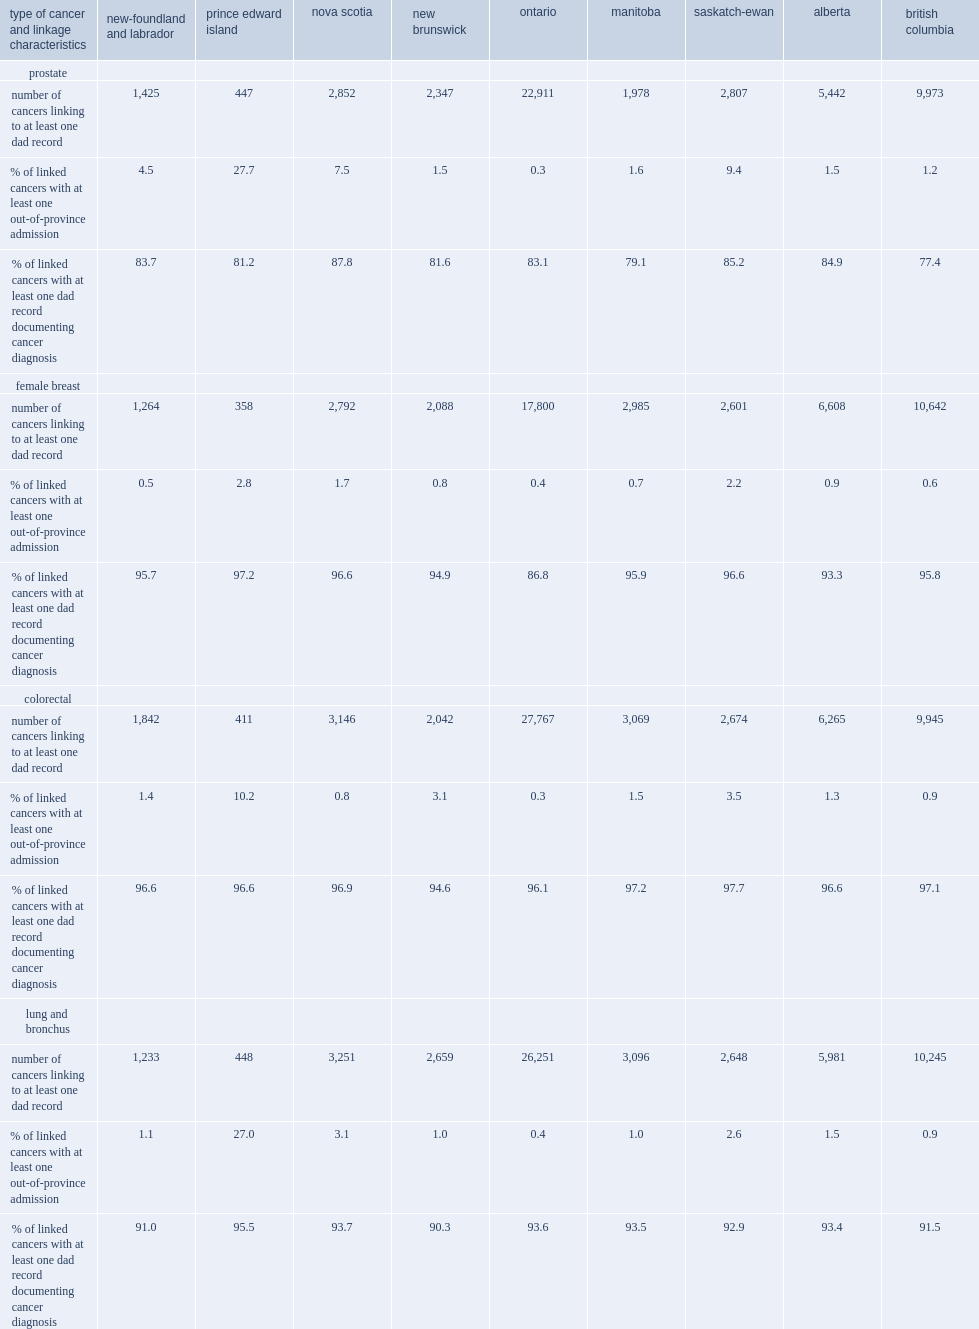List the cancer which was most likely and least likely to link to an out-of-province hospital admission respectively. Prostate female breast. For prostate cancers,which province had the highest percentage linking to at least one out-of-province admission? Prince edward island. List the cancer which was least likely and most likely to link to at least one dad record with a consistent cancer diagnosis respectively. Prostate colorectal. Could you parse the entire table? {'header': ['type of cancer and linkage characteristics', 'new-foundland and labrador', 'prince edward island', 'nova scotia', 'new brunswick', 'ontario', 'manitoba', 'saskatch-ewan', 'alberta', 'british columbia'], 'rows': [['prostate', '', '', '', '', '', '', '', '', ''], ['number of cancers linking to at least one dad record', '1,425', '447', '2,852', '2,347', '22,911', '1,978', '2,807', '5,442', '9,973'], ['% of linked cancers with at least one out-of-province admission', '4.5', '27.7', '7.5', '1.5', '0.3', '1.6', '9.4', '1.5', '1.2'], ['% of linked cancers with at least one dad record documenting cancer diagnosis', '83.7', '81.2', '87.8', '81.6', '83.1', '79.1', '85.2', '84.9', '77.4'], ['female breast', '', '', '', '', '', '', '', '', ''], ['number of cancers linking to at least one dad record', '1,264', '358', '2,792', '2,088', '17,800', '2,985', '2,601', '6,608', '10,642'], ['% of linked cancers with at least one out-of-province admission', '0.5', '2.8', '1.7', '0.8', '0.4', '0.7', '2.2', '0.9', '0.6'], ['% of linked cancers with at least one dad record documenting cancer diagnosis', '95.7', '97.2', '96.6', '94.9', '86.8', '95.9', '96.6', '93.3', '95.8'], ['colorectal', '', '', '', '', '', '', '', '', ''], ['number of cancers linking to at least one dad record', '1,842', '411', '3,146', '2,042', '27,767', '3,069', '2,674', '6,265', '9,945'], ['% of linked cancers with at least one out-of-province admission', '1.4', '10.2', '0.8', '3.1', '0.3', '1.5', '3.5', '1.3', '0.9'], ['% of linked cancers with at least one dad record documenting cancer diagnosis', '96.6', '96.6', '96.9', '94.6', '96.1', '97.2', '97.7', '96.6', '97.1'], ['lung and bronchus', '', '', '', '', '', '', '', '', ''], ['number of cancers linking to at least one dad record', '1,233', '448', '3,251', '2,659', '26,251', '3,096', '2,648', '5,981', '10,245'], ['% of linked cancers with at least one out-of-province admission', '1.1', '27.0', '3.1', '1.0', '0.4', '1.0', '2.6', '1.5', '0.9'], ['% of linked cancers with at least one dad record documenting cancer diagnosis', '91.0', '95.5', '93.7', '90.3', '93.6', '93.5', '92.9', '93.4', '91.5']]} 